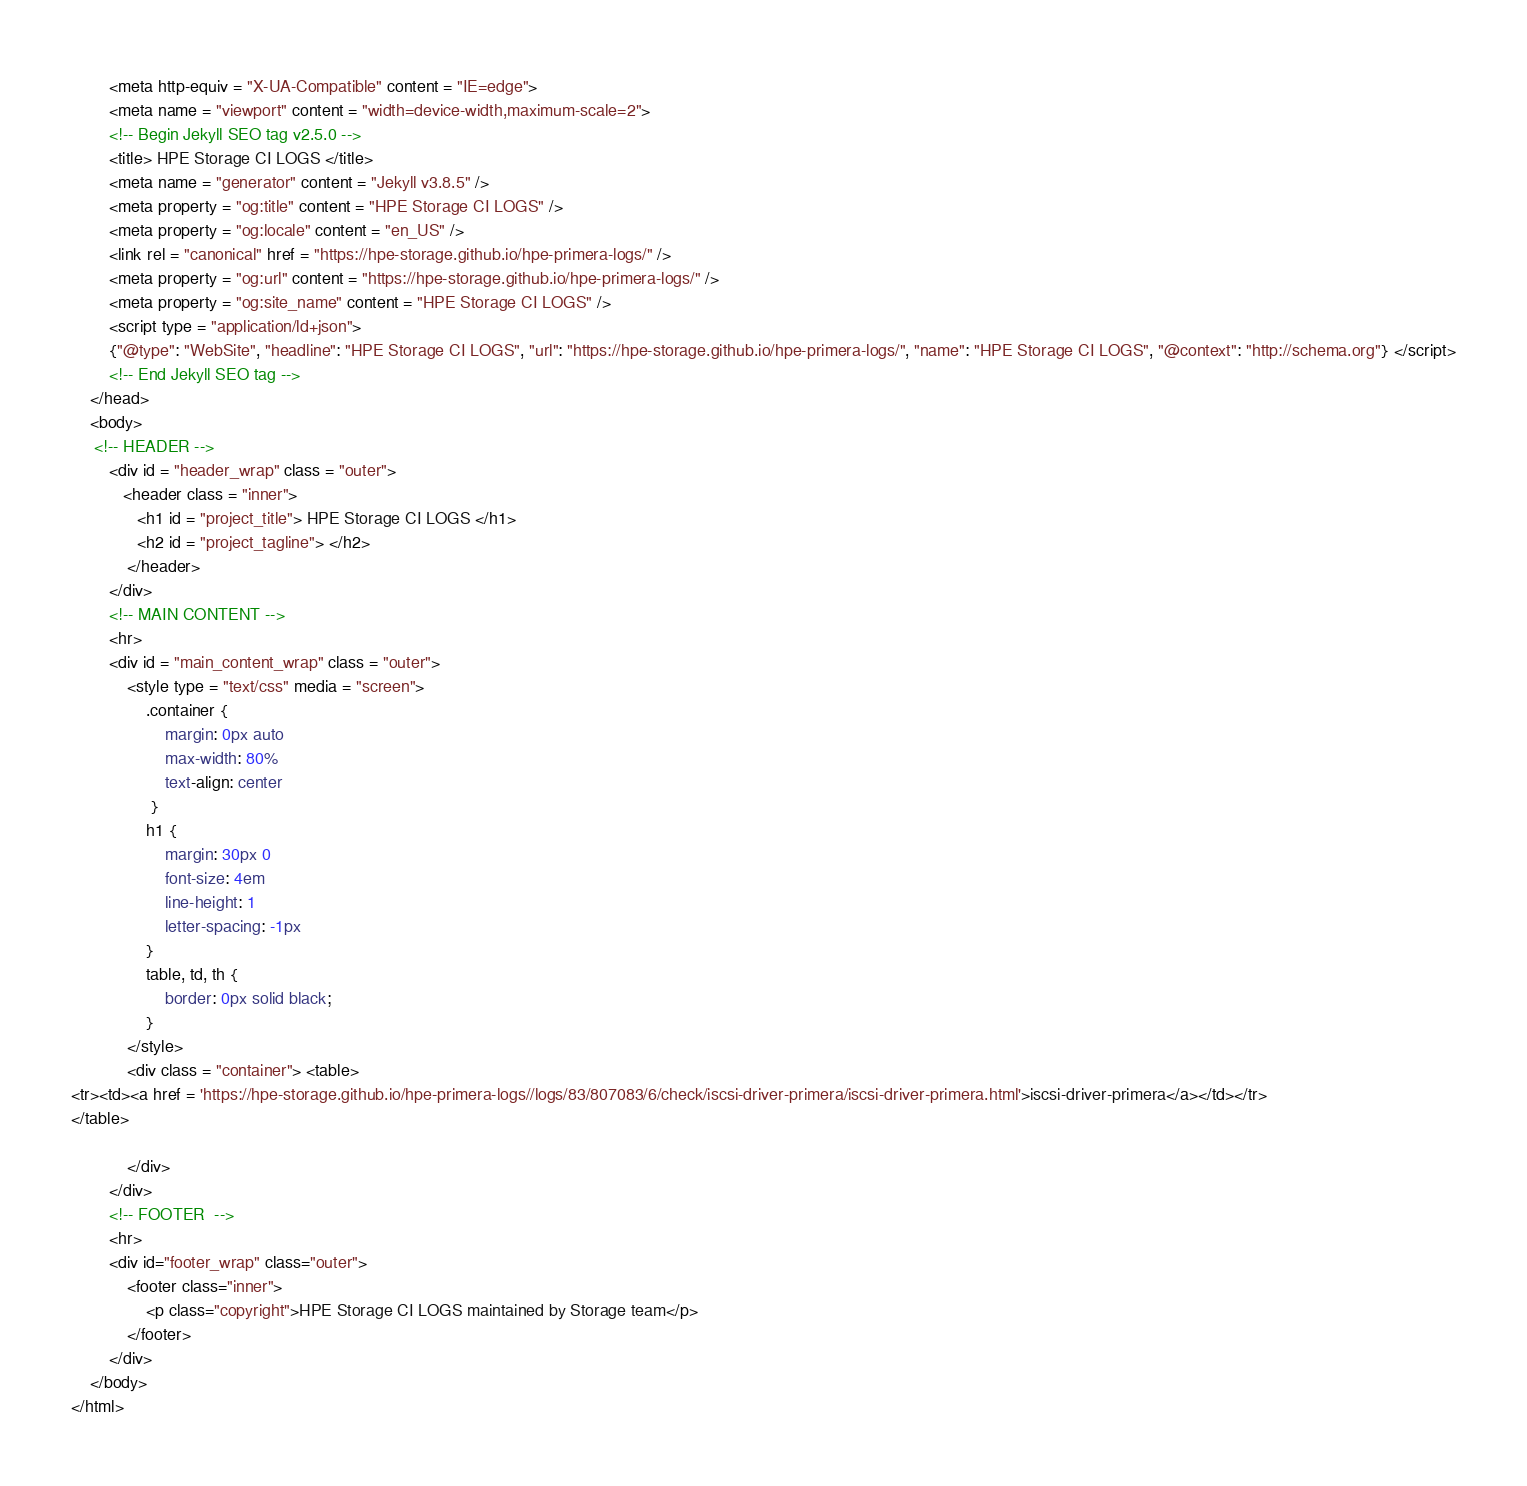Convert code to text. <code><loc_0><loc_0><loc_500><loc_500><_HTML_>        <meta http-equiv = "X-UA-Compatible" content = "IE=edge">
        <meta name = "viewport" content = "width=device-width,maximum-scale=2">
        <!-- Begin Jekyll SEO tag v2.5.0 -->
        <title> HPE Storage CI LOGS </title>
        <meta name = "generator" content = "Jekyll v3.8.5" />
        <meta property = "og:title" content = "HPE Storage CI LOGS" />
        <meta property = "og:locale" content = "en_US" />
        <link rel = "canonical" href = "https://hpe-storage.github.io/hpe-primera-logs/" />
        <meta property = "og:url" content = "https://hpe-storage.github.io/hpe-primera-logs/" />
        <meta property = "og:site_name" content = "HPE Storage CI LOGS" />
        <script type = "application/ld+json">
        {"@type": "WebSite", "headline": "HPE Storage CI LOGS", "url": "https://hpe-storage.github.io/hpe-primera-logs/", "name": "HPE Storage CI LOGS", "@context": "http://schema.org"} </script>
        <!-- End Jekyll SEO tag -->
    </head>
    <body>
     <!-- HEADER -->
        <div id = "header_wrap" class = "outer">
           <header class = "inner">
              <h1 id = "project_title"> HPE Storage CI LOGS </h1>
              <h2 id = "project_tagline"> </h2>
            </header>
        </div>
        <!-- MAIN CONTENT -->
        <hr>
        <div id = "main_content_wrap" class = "outer">
            <style type = "text/css" media = "screen">
                .container {
                    margin: 0px auto
                    max-width: 80%
                    text-align: center
                 }
                h1 {
                    margin: 30px 0
                    font-size: 4em
                    line-height: 1
                    letter-spacing: -1px
                }
                table, td, th {
                    border: 0px solid black;
                }
            </style>
            <div class = "container"> <table>
<tr><td><a href = 'https://hpe-storage.github.io/hpe-primera-logs//logs/83/807083/6/check/iscsi-driver-primera/iscsi-driver-primera.html'>iscsi-driver-primera</a></td></tr>
</table>

            </div>
        </div>
        <!-- FOOTER  -->
        <hr>
        <div id="footer_wrap" class="outer">
            <footer class="inner">
                <p class="copyright">HPE Storage CI LOGS maintained by Storage team</p>
            </footer>
        </div>
    </body>
</html>
</code> 